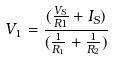Convert formula to latex. <formula><loc_0><loc_0><loc_500><loc_500>V _ { 1 } = \frac { ( \frac { V _ { S } } { R 1 } + I _ { S } ) } { ( \frac { 1 } { R _ { 1 } } + \frac { 1 } { R _ { 2 } } ) }</formula> 